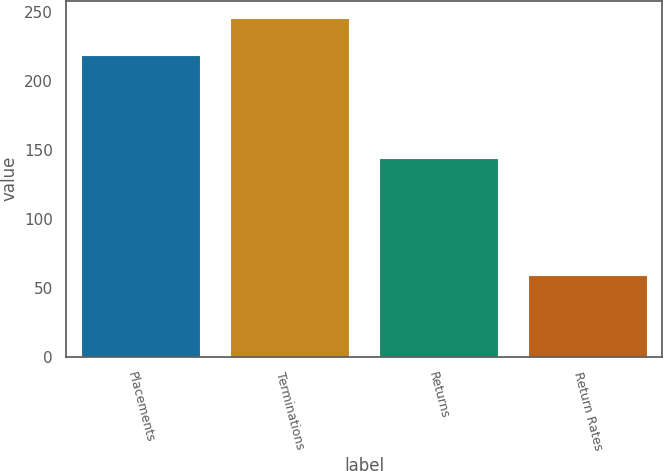Convert chart. <chart><loc_0><loc_0><loc_500><loc_500><bar_chart><fcel>Placements<fcel>Terminations<fcel>Returns<fcel>Return Rates<nl><fcel>219<fcel>246<fcel>144<fcel>59<nl></chart> 